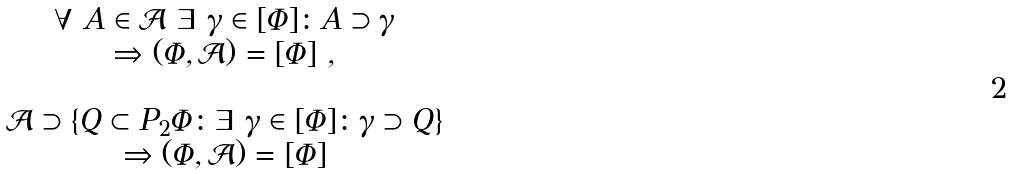Convert formula to latex. <formula><loc_0><loc_0><loc_500><loc_500>\begin{array} { c } \forall \ A \in \mathcal { A } \ \exists \ \gamma \in [ \Phi ] \colon A \supset \gamma \\ \Rightarrow ( \Phi , \mathcal { A } ) = [ \Phi ] \ , \\ \quad \\ \mathcal { A } \supset \{ Q \subset P _ { 2 } \Phi \colon \exists \ \gamma \in [ \Phi ] \colon \gamma \supset Q \} \\ \Rightarrow ( \Phi , \mathcal { A } ) = [ \Phi ] \end{array}</formula> 